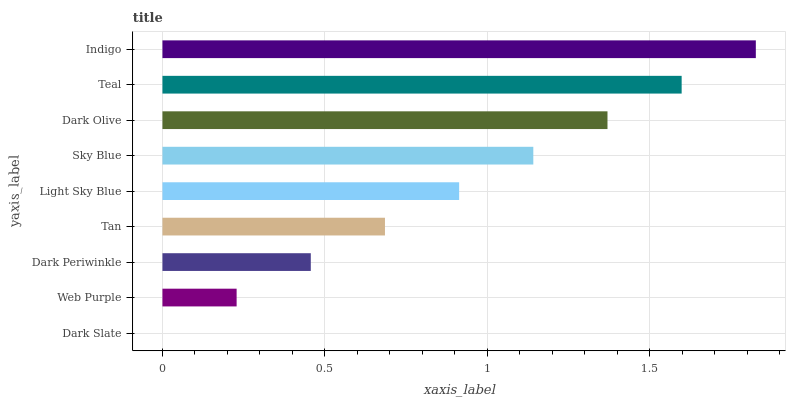Is Dark Slate the minimum?
Answer yes or no. Yes. Is Indigo the maximum?
Answer yes or no. Yes. Is Web Purple the minimum?
Answer yes or no. No. Is Web Purple the maximum?
Answer yes or no. No. Is Web Purple greater than Dark Slate?
Answer yes or no. Yes. Is Dark Slate less than Web Purple?
Answer yes or no. Yes. Is Dark Slate greater than Web Purple?
Answer yes or no. No. Is Web Purple less than Dark Slate?
Answer yes or no. No. Is Light Sky Blue the high median?
Answer yes or no. Yes. Is Light Sky Blue the low median?
Answer yes or no. Yes. Is Web Purple the high median?
Answer yes or no. No. Is Dark Olive the low median?
Answer yes or no. No. 